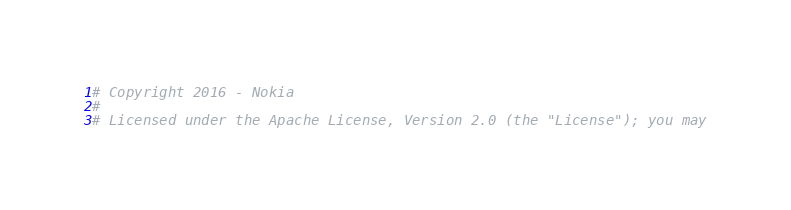<code> <loc_0><loc_0><loc_500><loc_500><_Python_># Copyright 2016 - Nokia
#
# Licensed under the Apache License, Version 2.0 (the "License"); you may</code> 